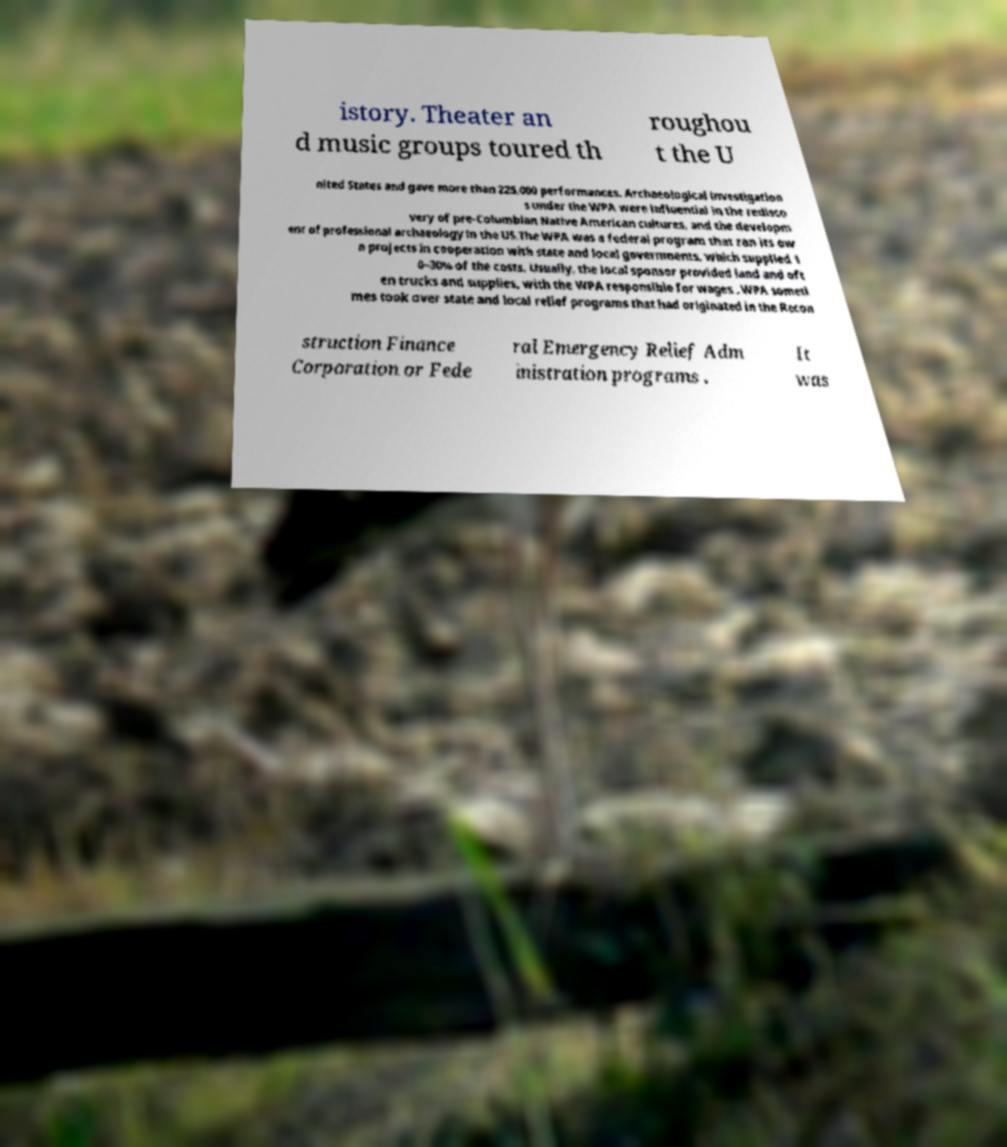What messages or text are displayed in this image? I need them in a readable, typed format. istory. Theater an d music groups toured th roughou t the U nited States and gave more than 225,000 performances. Archaeological investigation s under the WPA were influential in the redisco very of pre-Columbian Native American cultures, and the developm ent of professional archaeology in the US.The WPA was a federal program that ran its ow n projects in cooperation with state and local governments, which supplied 1 0–30% of the costs. Usually, the local sponsor provided land and oft en trucks and supplies, with the WPA responsible for wages . WPA someti mes took over state and local relief programs that had originated in the Recon struction Finance Corporation or Fede ral Emergency Relief Adm inistration programs . It was 